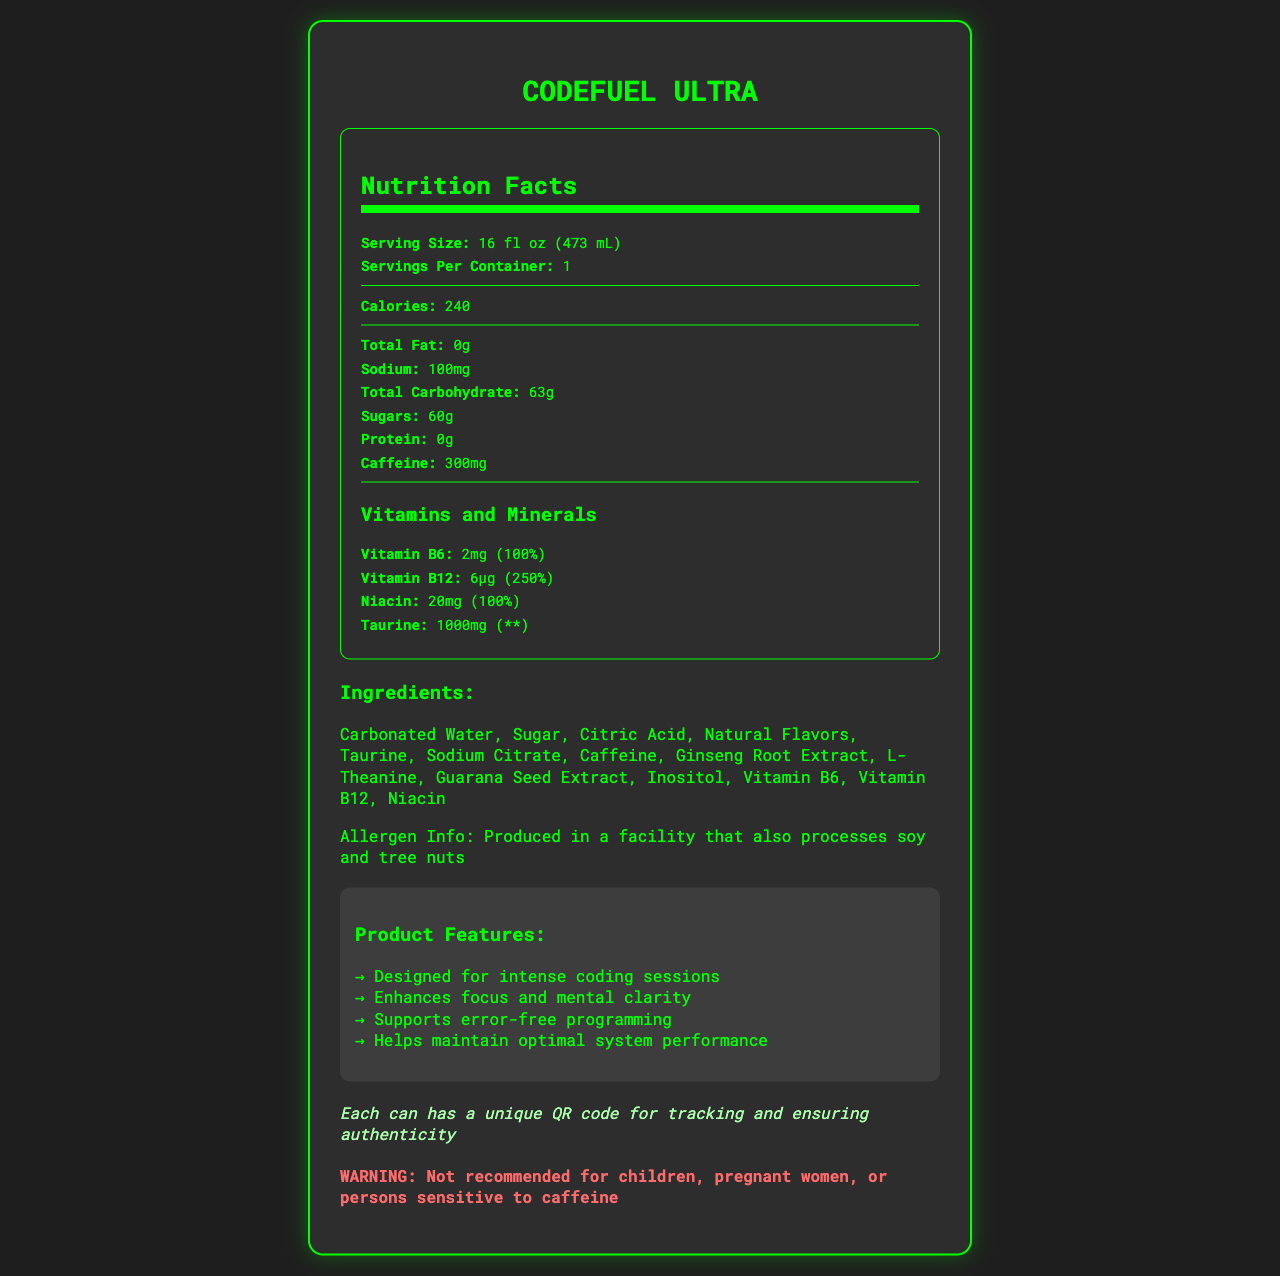what is the serving size of CodeFuel Ultra? The document lists the serving size as "16 fl oz (473 mL)" in the Nutrition Facts section.
Answer: 16 fl oz (473 mL) how many calories are in a container of CodeFuel Ultra? The Nutrition Facts section states that there are 240 calories per container.
Answer: 240 how much caffeine does CodeFuel Ultra contain? The amount of caffeine is explicitly mentioned as 300mg in the Nutrition Facts.
Answer: 300mg what are the top three ingredients in CodeFuel Ultra? The Ingredients section lists the ingredients in order with the top three as Carbonated Water, Sugar, and Citric Acid.
Answer: Carbonated Water, Sugar, Citric Acid how many grams of sugar are in CodeFuel Ultra? According to the Nutrition Facts, the total sugars are 60g.
Answer: 60g which vitamin provides the highest percentage of daily value? A. Vitamin B6 B. Vitamin B12 C. Niacin D. Taurine The Vitamin B12 provides 250% of the daily value, which is the highest among the listed vitamins and minerals.
Answer: B. Vitamin B12 how much Sodium is in CodeFuel Ultra? A. 0mg B. 50mg C. 100mg D. 150mg The Nutrition Facts section lists Sodium content as 100mg.
Answer: C. 100mg is CodeFuel Ultra recommended for children? The warning states, "Not recommended for children, pregnant women, or persons sensitive to caffeine."
Answer: No does CodeFuel Ultra contain any protein? The Nutrition Facts section indicates that the protein content is 0g.
Answer: No Based on the information provided, describe the entire document. The document comprehensively covers all the necessary details about "CodeFuel Ultra," formatted in a clear and organized manner to convey nutritional information, usage warnings, and product benefits effectively.
Answer: The document provides a detailed summary of the nutritional facts, ingredients, warnings, marketing claims, and a unique security feature of the energy drink "CodeFuel Ultra." It specifies the serving size, calorie count, and amounts of key ingredients including caffeine, vitamins, and minerals. Additionally, allergen information and product warnings are included along with a marketing section that highlights the drink's benefits for software developers. The security feature ensures product authenticity with a unique QR code on each can. what is the exact amount of Taurine in CodeFuel Ultra? The document specifies that "Taurine" is present in the amount of 1000mg.
Answer: 1000mg can this document tell us about the caffeine source of CodeFuel Ultra? The document only lists caffeine as an ingredient without specifying its source.
Answer: No, it cannot be determined what is the allergen information in CodeFuel Ultra? The document provides the allergen info stating it is produced in a facility that processes soy and tree nuts.
Answer: Produced in a facility that also processes soy and tree nuts which feature ensures the authenticity of each can of CodeFuel Ultra? The document mentions a unique QR code feature for security.
Answer: Each can has a unique QR code for tracking and ensuring authenticity 